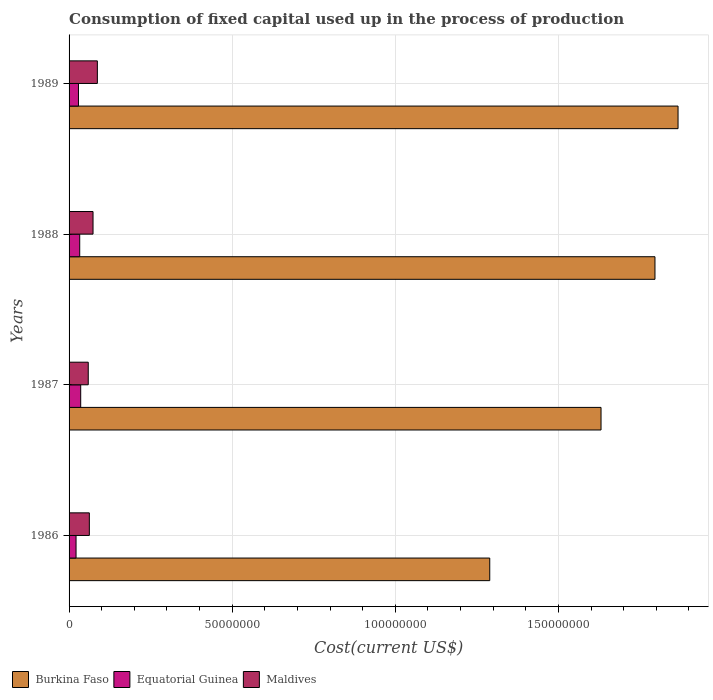How many different coloured bars are there?
Ensure brevity in your answer.  3. How many groups of bars are there?
Offer a very short reply. 4. Are the number of bars per tick equal to the number of legend labels?
Keep it short and to the point. Yes. What is the label of the 3rd group of bars from the top?
Keep it short and to the point. 1987. What is the amount consumed in the process of production in Burkina Faso in 1988?
Your answer should be very brief. 1.80e+08. Across all years, what is the maximum amount consumed in the process of production in Maldives?
Provide a short and direct response. 8.67e+06. Across all years, what is the minimum amount consumed in the process of production in Maldives?
Offer a very short reply. 5.88e+06. In which year was the amount consumed in the process of production in Maldives minimum?
Your answer should be very brief. 1987. What is the total amount consumed in the process of production in Maldives in the graph?
Make the answer very short. 2.81e+07. What is the difference between the amount consumed in the process of production in Equatorial Guinea in 1988 and that in 1989?
Your answer should be compact. 3.88e+05. What is the difference between the amount consumed in the process of production in Equatorial Guinea in 1989 and the amount consumed in the process of production in Burkina Faso in 1986?
Ensure brevity in your answer.  -1.26e+08. What is the average amount consumed in the process of production in Equatorial Guinea per year?
Offer a terse response. 2.96e+06. In the year 1986, what is the difference between the amount consumed in the process of production in Equatorial Guinea and amount consumed in the process of production in Maldives?
Give a very brief answer. -4.08e+06. What is the ratio of the amount consumed in the process of production in Burkina Faso in 1987 to that in 1989?
Your answer should be very brief. 0.87. Is the amount consumed in the process of production in Maldives in 1986 less than that in 1988?
Provide a short and direct response. Yes. What is the difference between the highest and the second highest amount consumed in the process of production in Equatorial Guinea?
Offer a very short reply. 2.98e+05. What is the difference between the highest and the lowest amount consumed in the process of production in Burkina Faso?
Your answer should be compact. 5.77e+07. In how many years, is the amount consumed in the process of production in Equatorial Guinea greater than the average amount consumed in the process of production in Equatorial Guinea taken over all years?
Provide a succinct answer. 2. Is the sum of the amount consumed in the process of production in Maldives in 1986 and 1987 greater than the maximum amount consumed in the process of production in Equatorial Guinea across all years?
Provide a short and direct response. Yes. What does the 3rd bar from the top in 1987 represents?
Provide a short and direct response. Burkina Faso. What does the 3rd bar from the bottom in 1987 represents?
Offer a very short reply. Maldives. How many years are there in the graph?
Your answer should be very brief. 4. Are the values on the major ticks of X-axis written in scientific E-notation?
Give a very brief answer. No. Where does the legend appear in the graph?
Your answer should be very brief. Bottom left. How many legend labels are there?
Make the answer very short. 3. What is the title of the graph?
Ensure brevity in your answer.  Consumption of fixed capital used up in the process of production. Does "Channel Islands" appear as one of the legend labels in the graph?
Provide a succinct answer. No. What is the label or title of the X-axis?
Provide a succinct answer. Cost(current US$). What is the label or title of the Y-axis?
Make the answer very short. Years. What is the Cost(current US$) of Burkina Faso in 1986?
Your answer should be very brief. 1.29e+08. What is the Cost(current US$) in Equatorial Guinea in 1986?
Provide a short and direct response. 2.14e+06. What is the Cost(current US$) in Maldives in 1986?
Offer a terse response. 6.21e+06. What is the Cost(current US$) in Burkina Faso in 1987?
Give a very brief answer. 1.63e+08. What is the Cost(current US$) of Equatorial Guinea in 1987?
Provide a succinct answer. 3.56e+06. What is the Cost(current US$) in Maldives in 1987?
Offer a very short reply. 5.88e+06. What is the Cost(current US$) of Burkina Faso in 1988?
Your response must be concise. 1.80e+08. What is the Cost(current US$) of Equatorial Guinea in 1988?
Offer a terse response. 3.27e+06. What is the Cost(current US$) of Maldives in 1988?
Ensure brevity in your answer.  7.34e+06. What is the Cost(current US$) of Burkina Faso in 1989?
Make the answer very short. 1.87e+08. What is the Cost(current US$) of Equatorial Guinea in 1989?
Provide a short and direct response. 2.88e+06. What is the Cost(current US$) in Maldives in 1989?
Your response must be concise. 8.67e+06. Across all years, what is the maximum Cost(current US$) of Burkina Faso?
Provide a short and direct response. 1.87e+08. Across all years, what is the maximum Cost(current US$) in Equatorial Guinea?
Keep it short and to the point. 3.56e+06. Across all years, what is the maximum Cost(current US$) of Maldives?
Keep it short and to the point. 8.67e+06. Across all years, what is the minimum Cost(current US$) of Burkina Faso?
Keep it short and to the point. 1.29e+08. Across all years, what is the minimum Cost(current US$) of Equatorial Guinea?
Your answer should be compact. 2.14e+06. Across all years, what is the minimum Cost(current US$) in Maldives?
Offer a terse response. 5.88e+06. What is the total Cost(current US$) of Burkina Faso in the graph?
Your answer should be very brief. 6.58e+08. What is the total Cost(current US$) in Equatorial Guinea in the graph?
Keep it short and to the point. 1.18e+07. What is the total Cost(current US$) of Maldives in the graph?
Your answer should be compact. 2.81e+07. What is the difference between the Cost(current US$) of Burkina Faso in 1986 and that in 1987?
Ensure brevity in your answer.  -3.41e+07. What is the difference between the Cost(current US$) in Equatorial Guinea in 1986 and that in 1987?
Provide a short and direct response. -1.42e+06. What is the difference between the Cost(current US$) in Maldives in 1986 and that in 1987?
Ensure brevity in your answer.  3.35e+05. What is the difference between the Cost(current US$) in Burkina Faso in 1986 and that in 1988?
Offer a terse response. -5.06e+07. What is the difference between the Cost(current US$) in Equatorial Guinea in 1986 and that in 1988?
Your answer should be compact. -1.13e+06. What is the difference between the Cost(current US$) of Maldives in 1986 and that in 1988?
Your answer should be very brief. -1.13e+06. What is the difference between the Cost(current US$) in Burkina Faso in 1986 and that in 1989?
Make the answer very short. -5.77e+07. What is the difference between the Cost(current US$) of Equatorial Guinea in 1986 and that in 1989?
Your response must be concise. -7.39e+05. What is the difference between the Cost(current US$) of Maldives in 1986 and that in 1989?
Offer a very short reply. -2.46e+06. What is the difference between the Cost(current US$) in Burkina Faso in 1987 and that in 1988?
Your answer should be compact. -1.65e+07. What is the difference between the Cost(current US$) of Equatorial Guinea in 1987 and that in 1988?
Your answer should be very brief. 2.98e+05. What is the difference between the Cost(current US$) of Maldives in 1987 and that in 1988?
Make the answer very short. -1.46e+06. What is the difference between the Cost(current US$) in Burkina Faso in 1987 and that in 1989?
Your response must be concise. -2.36e+07. What is the difference between the Cost(current US$) in Equatorial Guinea in 1987 and that in 1989?
Provide a succinct answer. 6.85e+05. What is the difference between the Cost(current US$) of Maldives in 1987 and that in 1989?
Your response must be concise. -2.79e+06. What is the difference between the Cost(current US$) in Burkina Faso in 1988 and that in 1989?
Your answer should be very brief. -7.07e+06. What is the difference between the Cost(current US$) of Equatorial Guinea in 1988 and that in 1989?
Your answer should be compact. 3.88e+05. What is the difference between the Cost(current US$) of Maldives in 1988 and that in 1989?
Make the answer very short. -1.33e+06. What is the difference between the Cost(current US$) of Burkina Faso in 1986 and the Cost(current US$) of Equatorial Guinea in 1987?
Offer a very short reply. 1.25e+08. What is the difference between the Cost(current US$) of Burkina Faso in 1986 and the Cost(current US$) of Maldives in 1987?
Ensure brevity in your answer.  1.23e+08. What is the difference between the Cost(current US$) of Equatorial Guinea in 1986 and the Cost(current US$) of Maldives in 1987?
Provide a succinct answer. -3.74e+06. What is the difference between the Cost(current US$) of Burkina Faso in 1986 and the Cost(current US$) of Equatorial Guinea in 1988?
Your answer should be compact. 1.26e+08. What is the difference between the Cost(current US$) of Burkina Faso in 1986 and the Cost(current US$) of Maldives in 1988?
Your answer should be very brief. 1.22e+08. What is the difference between the Cost(current US$) in Equatorial Guinea in 1986 and the Cost(current US$) in Maldives in 1988?
Give a very brief answer. -5.20e+06. What is the difference between the Cost(current US$) in Burkina Faso in 1986 and the Cost(current US$) in Equatorial Guinea in 1989?
Give a very brief answer. 1.26e+08. What is the difference between the Cost(current US$) in Burkina Faso in 1986 and the Cost(current US$) in Maldives in 1989?
Offer a very short reply. 1.20e+08. What is the difference between the Cost(current US$) of Equatorial Guinea in 1986 and the Cost(current US$) of Maldives in 1989?
Offer a very short reply. -6.53e+06. What is the difference between the Cost(current US$) of Burkina Faso in 1987 and the Cost(current US$) of Equatorial Guinea in 1988?
Provide a short and direct response. 1.60e+08. What is the difference between the Cost(current US$) of Burkina Faso in 1987 and the Cost(current US$) of Maldives in 1988?
Your answer should be compact. 1.56e+08. What is the difference between the Cost(current US$) in Equatorial Guinea in 1987 and the Cost(current US$) in Maldives in 1988?
Offer a terse response. -3.78e+06. What is the difference between the Cost(current US$) of Burkina Faso in 1987 and the Cost(current US$) of Equatorial Guinea in 1989?
Provide a succinct answer. 1.60e+08. What is the difference between the Cost(current US$) of Burkina Faso in 1987 and the Cost(current US$) of Maldives in 1989?
Offer a terse response. 1.54e+08. What is the difference between the Cost(current US$) of Equatorial Guinea in 1987 and the Cost(current US$) of Maldives in 1989?
Give a very brief answer. -5.11e+06. What is the difference between the Cost(current US$) of Burkina Faso in 1988 and the Cost(current US$) of Equatorial Guinea in 1989?
Provide a succinct answer. 1.77e+08. What is the difference between the Cost(current US$) of Burkina Faso in 1988 and the Cost(current US$) of Maldives in 1989?
Offer a very short reply. 1.71e+08. What is the difference between the Cost(current US$) in Equatorial Guinea in 1988 and the Cost(current US$) in Maldives in 1989?
Offer a terse response. -5.41e+06. What is the average Cost(current US$) in Burkina Faso per year?
Your answer should be compact. 1.65e+08. What is the average Cost(current US$) of Equatorial Guinea per year?
Give a very brief answer. 2.96e+06. What is the average Cost(current US$) in Maldives per year?
Give a very brief answer. 7.03e+06. In the year 1986, what is the difference between the Cost(current US$) in Burkina Faso and Cost(current US$) in Equatorial Guinea?
Make the answer very short. 1.27e+08. In the year 1986, what is the difference between the Cost(current US$) of Burkina Faso and Cost(current US$) of Maldives?
Your answer should be compact. 1.23e+08. In the year 1986, what is the difference between the Cost(current US$) in Equatorial Guinea and Cost(current US$) in Maldives?
Ensure brevity in your answer.  -4.08e+06. In the year 1987, what is the difference between the Cost(current US$) in Burkina Faso and Cost(current US$) in Equatorial Guinea?
Offer a terse response. 1.59e+08. In the year 1987, what is the difference between the Cost(current US$) of Burkina Faso and Cost(current US$) of Maldives?
Ensure brevity in your answer.  1.57e+08. In the year 1987, what is the difference between the Cost(current US$) in Equatorial Guinea and Cost(current US$) in Maldives?
Make the answer very short. -2.32e+06. In the year 1988, what is the difference between the Cost(current US$) in Burkina Faso and Cost(current US$) in Equatorial Guinea?
Ensure brevity in your answer.  1.76e+08. In the year 1988, what is the difference between the Cost(current US$) in Burkina Faso and Cost(current US$) in Maldives?
Offer a very short reply. 1.72e+08. In the year 1988, what is the difference between the Cost(current US$) of Equatorial Guinea and Cost(current US$) of Maldives?
Your response must be concise. -4.08e+06. In the year 1989, what is the difference between the Cost(current US$) in Burkina Faso and Cost(current US$) in Equatorial Guinea?
Make the answer very short. 1.84e+08. In the year 1989, what is the difference between the Cost(current US$) of Burkina Faso and Cost(current US$) of Maldives?
Your answer should be very brief. 1.78e+08. In the year 1989, what is the difference between the Cost(current US$) in Equatorial Guinea and Cost(current US$) in Maldives?
Provide a succinct answer. -5.79e+06. What is the ratio of the Cost(current US$) in Burkina Faso in 1986 to that in 1987?
Keep it short and to the point. 0.79. What is the ratio of the Cost(current US$) of Equatorial Guinea in 1986 to that in 1987?
Offer a very short reply. 0.6. What is the ratio of the Cost(current US$) of Maldives in 1986 to that in 1987?
Ensure brevity in your answer.  1.06. What is the ratio of the Cost(current US$) in Burkina Faso in 1986 to that in 1988?
Give a very brief answer. 0.72. What is the ratio of the Cost(current US$) in Equatorial Guinea in 1986 to that in 1988?
Offer a terse response. 0.66. What is the ratio of the Cost(current US$) of Maldives in 1986 to that in 1988?
Your answer should be very brief. 0.85. What is the ratio of the Cost(current US$) of Burkina Faso in 1986 to that in 1989?
Keep it short and to the point. 0.69. What is the ratio of the Cost(current US$) in Equatorial Guinea in 1986 to that in 1989?
Make the answer very short. 0.74. What is the ratio of the Cost(current US$) of Maldives in 1986 to that in 1989?
Ensure brevity in your answer.  0.72. What is the ratio of the Cost(current US$) in Burkina Faso in 1987 to that in 1988?
Your response must be concise. 0.91. What is the ratio of the Cost(current US$) of Equatorial Guinea in 1987 to that in 1988?
Offer a terse response. 1.09. What is the ratio of the Cost(current US$) in Maldives in 1987 to that in 1988?
Provide a short and direct response. 0.8. What is the ratio of the Cost(current US$) in Burkina Faso in 1987 to that in 1989?
Offer a terse response. 0.87. What is the ratio of the Cost(current US$) in Equatorial Guinea in 1987 to that in 1989?
Your answer should be very brief. 1.24. What is the ratio of the Cost(current US$) in Maldives in 1987 to that in 1989?
Provide a succinct answer. 0.68. What is the ratio of the Cost(current US$) of Burkina Faso in 1988 to that in 1989?
Give a very brief answer. 0.96. What is the ratio of the Cost(current US$) in Equatorial Guinea in 1988 to that in 1989?
Give a very brief answer. 1.13. What is the ratio of the Cost(current US$) in Maldives in 1988 to that in 1989?
Your response must be concise. 0.85. What is the difference between the highest and the second highest Cost(current US$) in Burkina Faso?
Provide a short and direct response. 7.07e+06. What is the difference between the highest and the second highest Cost(current US$) of Equatorial Guinea?
Your answer should be compact. 2.98e+05. What is the difference between the highest and the second highest Cost(current US$) in Maldives?
Offer a very short reply. 1.33e+06. What is the difference between the highest and the lowest Cost(current US$) of Burkina Faso?
Your answer should be compact. 5.77e+07. What is the difference between the highest and the lowest Cost(current US$) of Equatorial Guinea?
Your answer should be very brief. 1.42e+06. What is the difference between the highest and the lowest Cost(current US$) in Maldives?
Provide a short and direct response. 2.79e+06. 